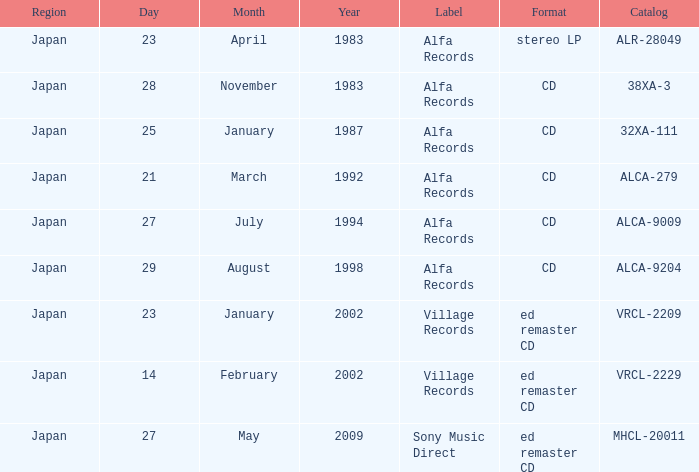Which date is in CD format? November 28, 1983, January 25, 1987, March 21, 1992, July 27, 1994, August 29, 1998. 